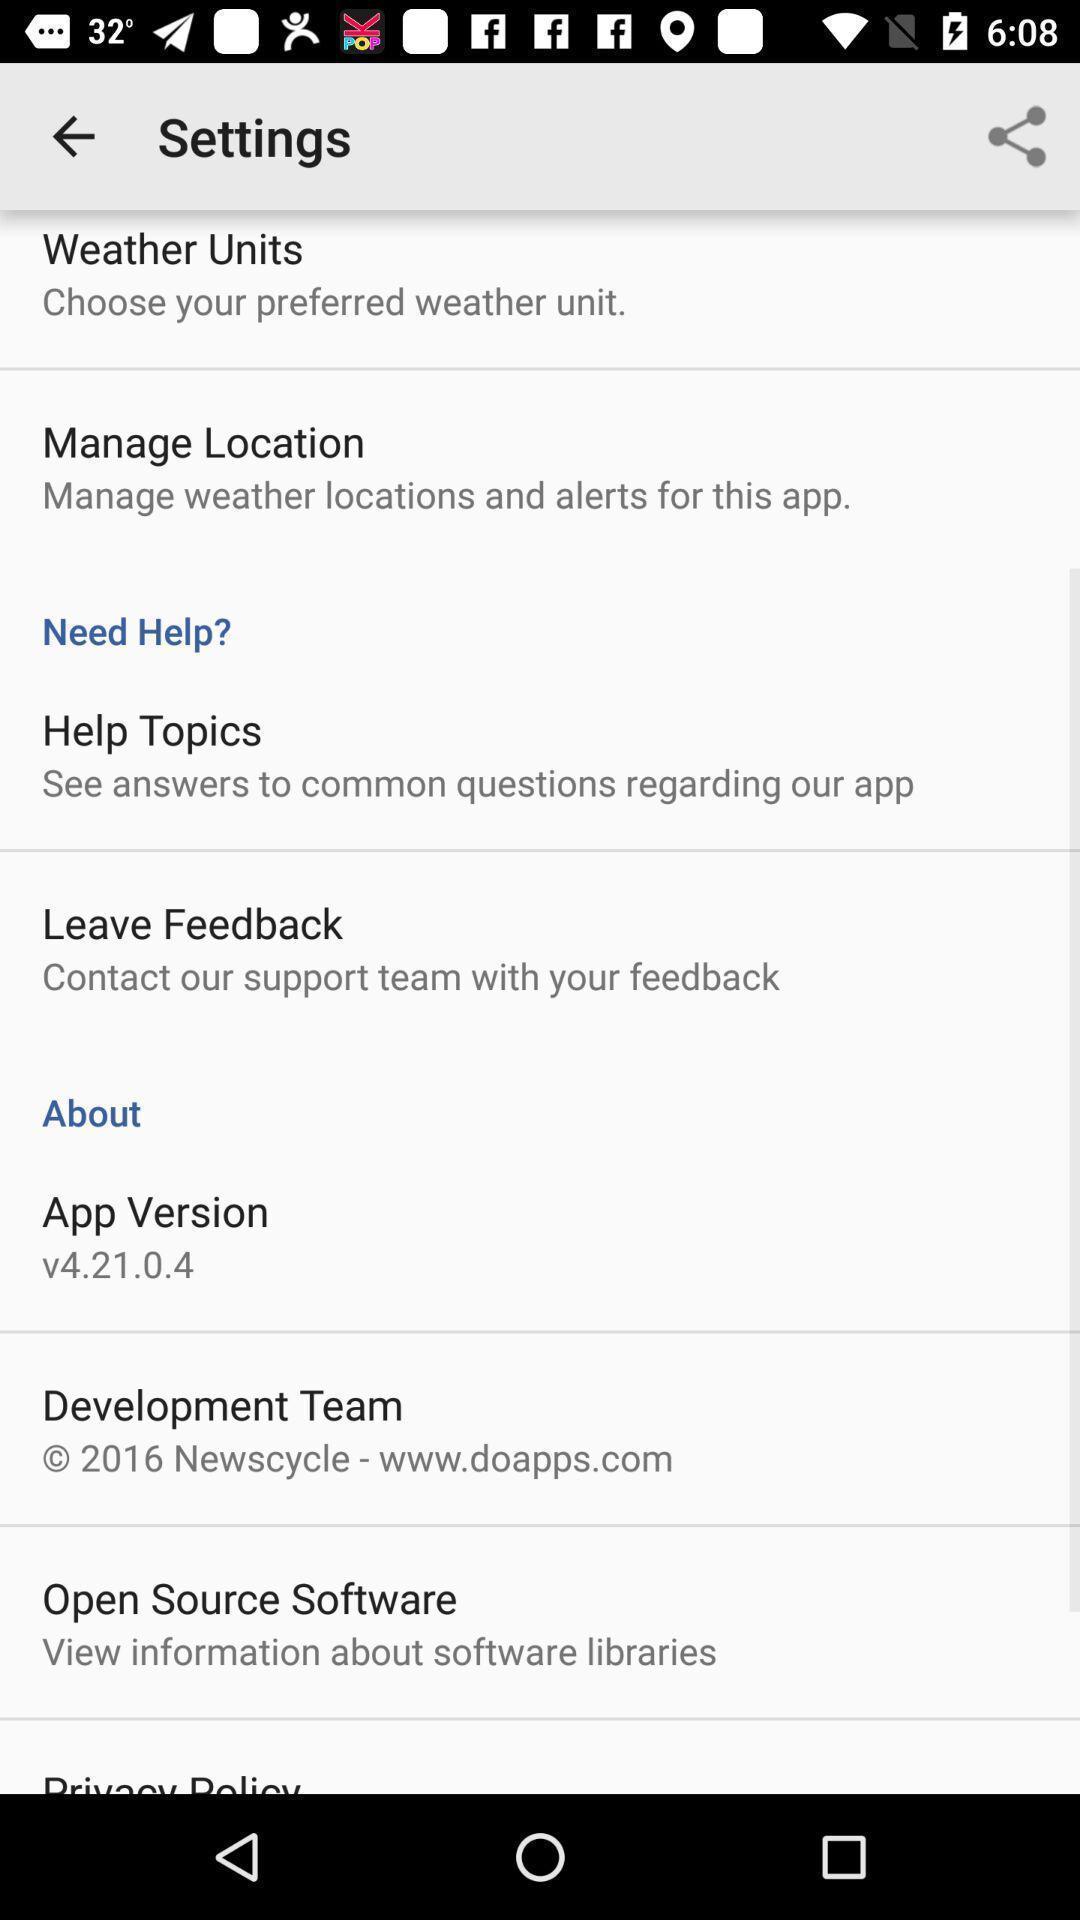Summarize the main components in this picture. Settings page of a weather app. 